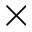<formula> <loc_0><loc_0><loc_500><loc_500>\times</formula> 